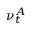<formula> <loc_0><loc_0><loc_500><loc_500>\nu _ { t } ^ { A }</formula> 